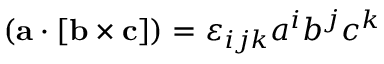Convert formula to latex. <formula><loc_0><loc_0><loc_500><loc_500>( a \cdot [ b \times c ] ) = \varepsilon _ { i j k } a ^ { i } b ^ { j } c ^ { k }</formula> 